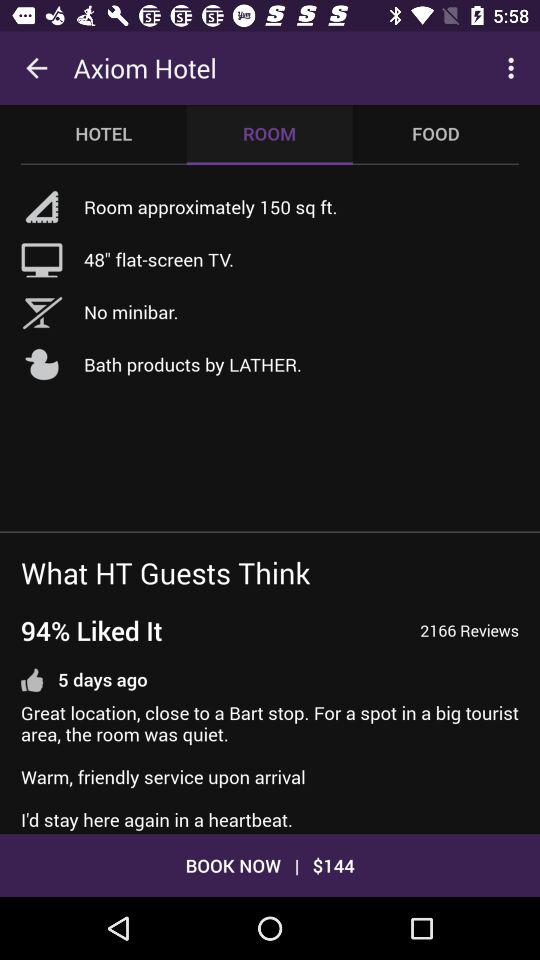What is the price of the Axiom Hotel? The price is $144. 